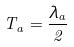<formula> <loc_0><loc_0><loc_500><loc_500>T _ { a } = \frac { \lambda _ { a } } { 2 }</formula> 